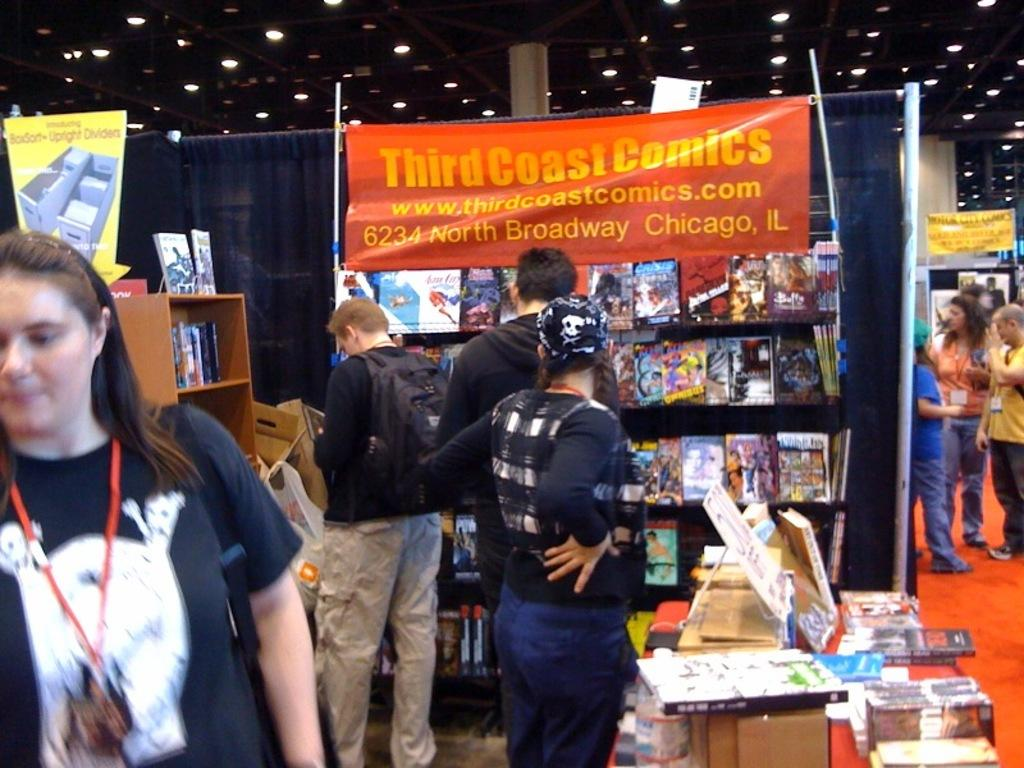<image>
Describe the image concisely. people at a store that has a banner in it that says 'third coast comics' 